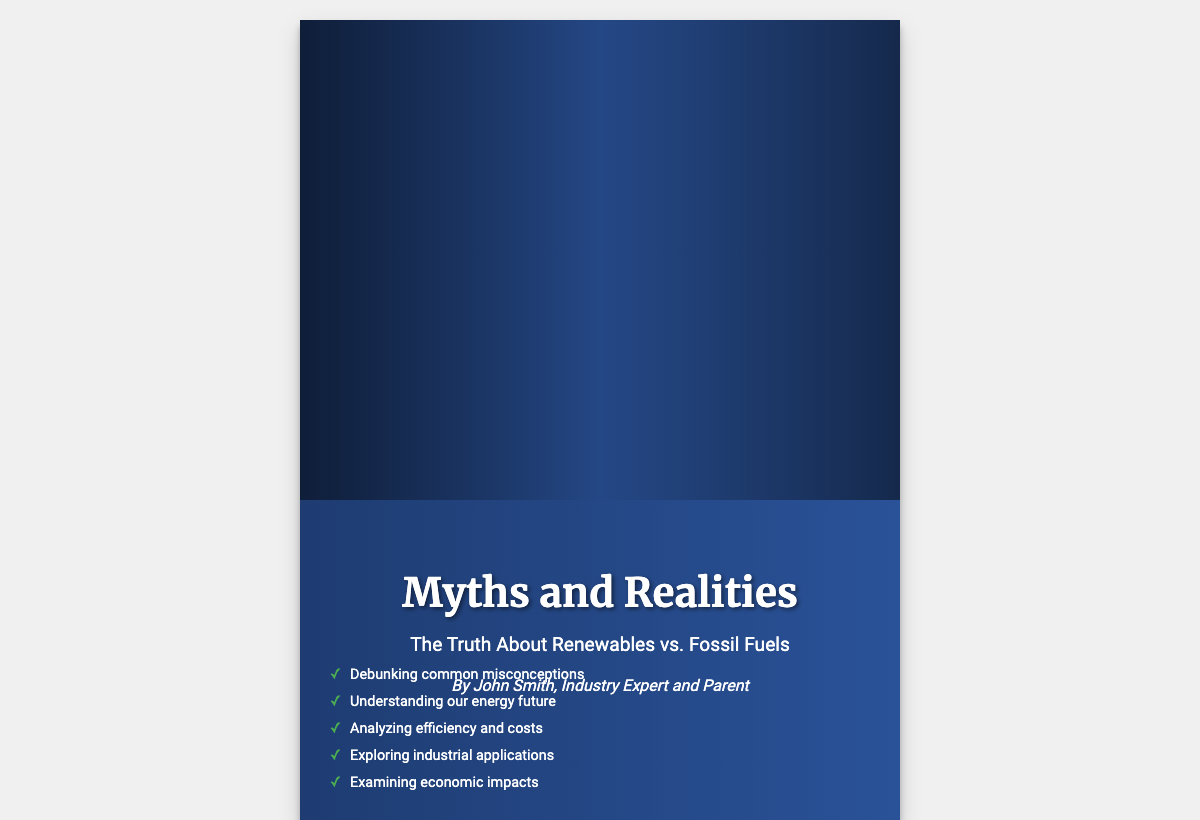what is the title of the book? The title is prominently displayed on the cover of the book.
Answer: Myths and Realities who is the author of the book? The author is mentioned just below the title.
Answer: John Smith what are the two energy sources depicted on the cover? The cover features split images that represent two different energy sources.
Answer: oil platform and wind turbines how many key points are listed on the cover? The number of key points can be counted as they are displayed at the bottom of the cover.
Answer: five what is one of the key points mentioned? One of the key points is explicitly stated on the cover.
Answer: Debunking common misconceptions what does the cover emphasize visually? The visual elements contrast two different energy approaches.
Answer: contrasting energy sources what is the primary color scheme used for the cover? The color scheme consists of specific colors throughout the design.
Answer: blue and black 